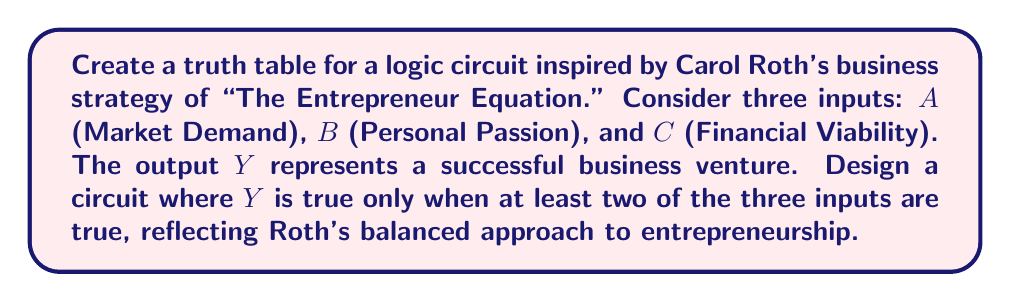Provide a solution to this math problem. To create the truth table for this logic circuit inspired by Carol Roth's business strategy, we'll follow these steps:

1) First, let's define our inputs and output:
   A: Market Demand
   B: Personal Passion
   C: Financial Viability
   Y: Successful Business Venture

2) The condition for Y to be true is when at least two of the three inputs are true. This can be represented by the following Boolean expression:

   $Y = AB + AC + BC$

3) Now, let's create the truth table with all possible combinations of inputs:

   | A | B | C | Y |
   |---|---|---|---|
   | 0 | 0 | 0 | 0 |
   | 0 | 0 | 1 | 0 |
   | 0 | 1 | 0 | 0 |
   | 0 | 1 | 1 | 1 |
   | 1 | 0 | 0 | 0 |
   | 1 | 0 | 1 | 1 |
   | 1 | 1 | 0 | 1 |
   | 1 | 1 | 1 | 1 |

4) To verify each row, we can substitute the values into our Boolean expression:

   For example, when A=0, B=1, C=1:
   $Y = (0 \cdot 1) + (0 \cdot 1) + (1 \cdot 1) = 0 + 0 + 1 = 1$

5) The resulting truth table reflects Carol Roth's balanced approach to entrepreneurship, where success (Y=1) is achieved when at least two of the three crucial factors (Market Demand, Personal Passion, and Financial Viability) are present.
Answer: $$Y = AB + AC + BC$$ 